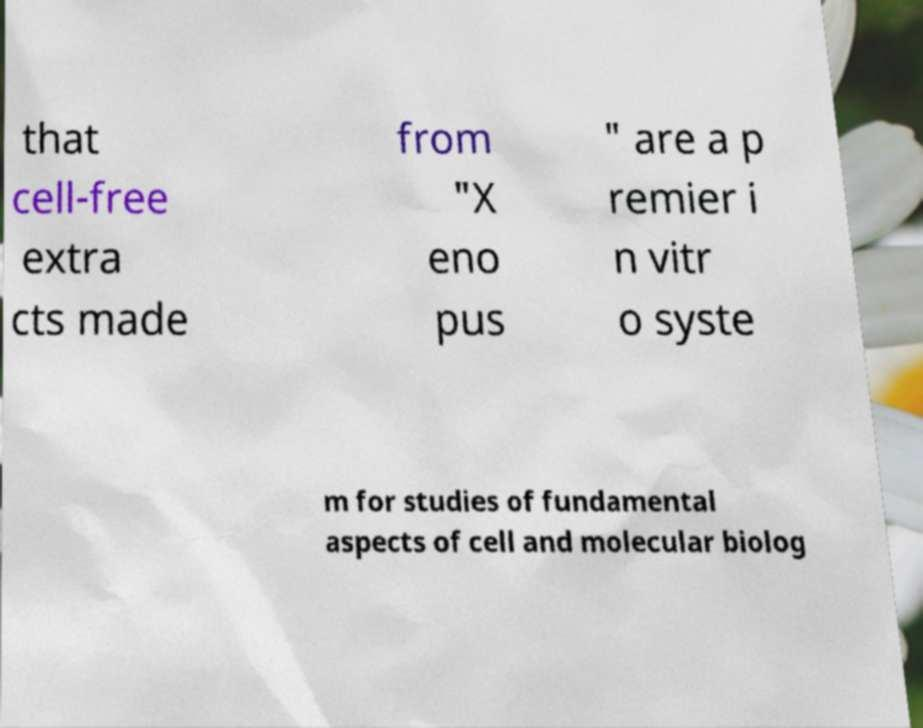I need the written content from this picture converted into text. Can you do that? that cell-free extra cts made from "X eno pus " are a p remier i n vitr o syste m for studies of fundamental aspects of cell and molecular biolog 